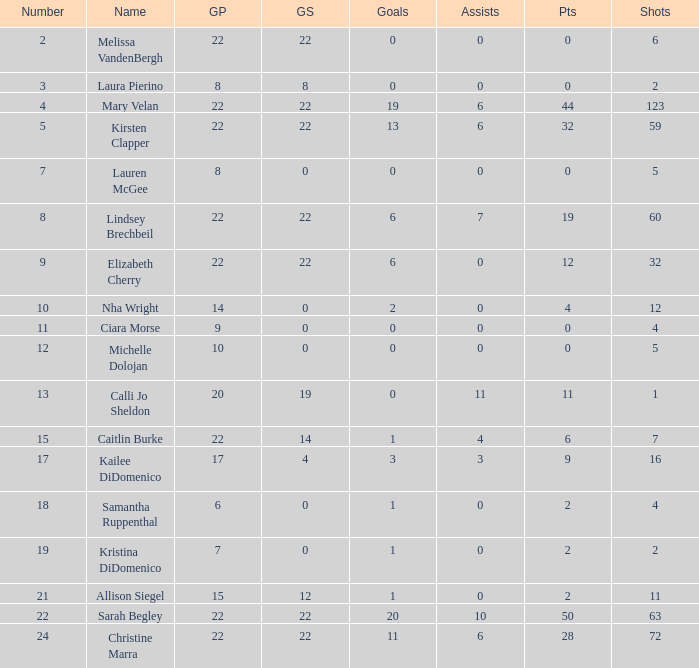How many names are listed for the player with 50 points? 1.0. 